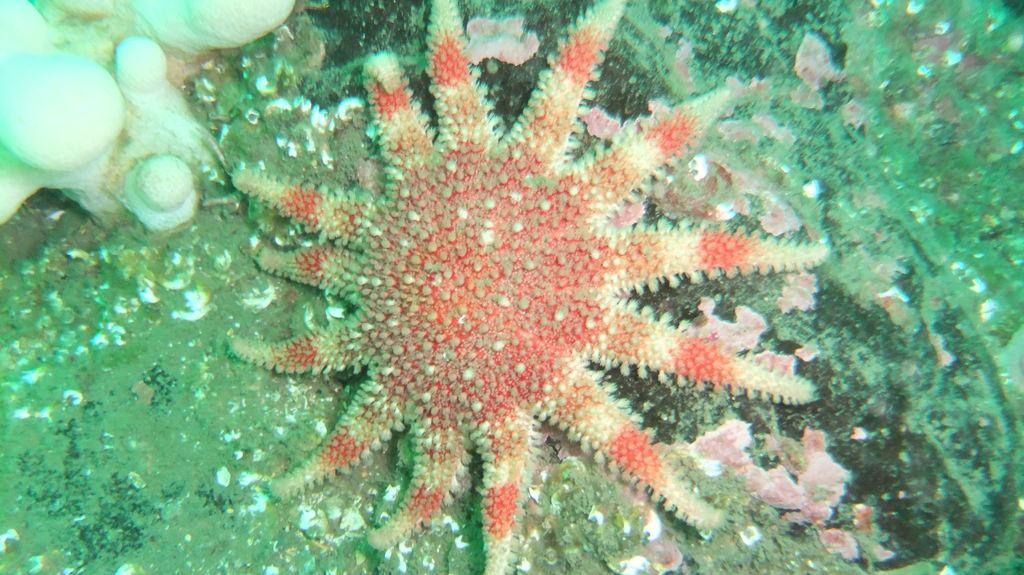What is the main subject of the image? There is a flower in the image. What type of quill can be seen next to the flower in the image? There is no quill present in the image; it only features a flower. 